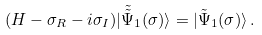<formula> <loc_0><loc_0><loc_500><loc_500>( H - \sigma _ { R } - i \sigma _ { I } ) | \tilde { \tilde { \Psi } } _ { 1 } ( \sigma ) \rangle = | \tilde { \Psi } _ { 1 } ( \sigma ) \rangle \, .</formula> 